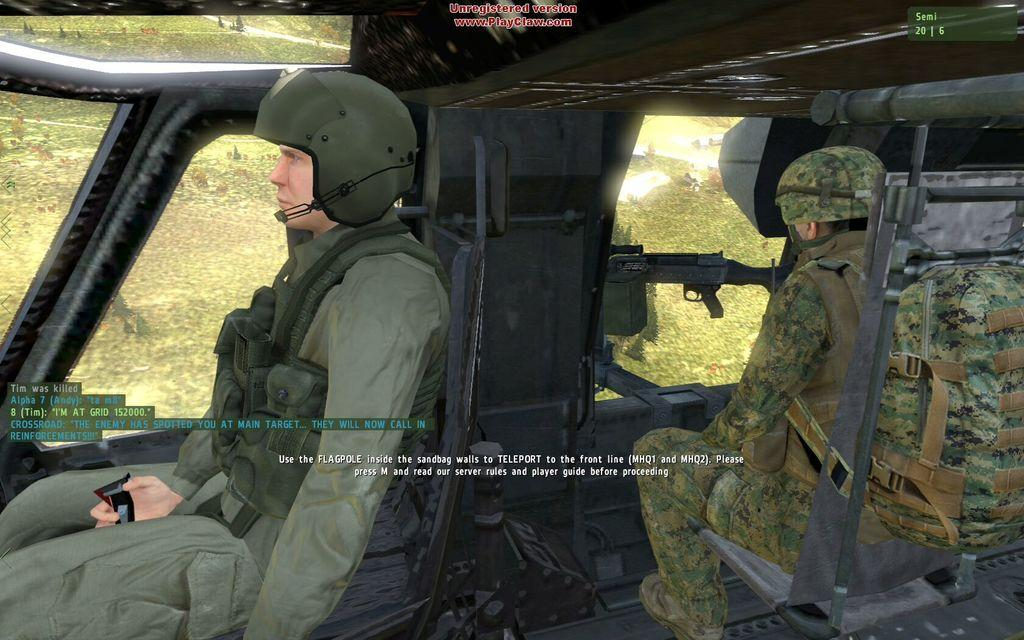What type of image is this? The image appears to be an animation. What can be seen in the image? There are two military persons in the image. Where are the military persons located? The military persons are sitting in a vehicle. What weapons are visible in the image? There are guns visible in the image. What type of roof can be seen in the image? There is no roof present in the image; it features two military persons sitting in a vehicle. What discovery was made by the military persons in the image? There is no indication of a discovery in the image; it simply shows two military persons sitting in a vehicle with guns. 